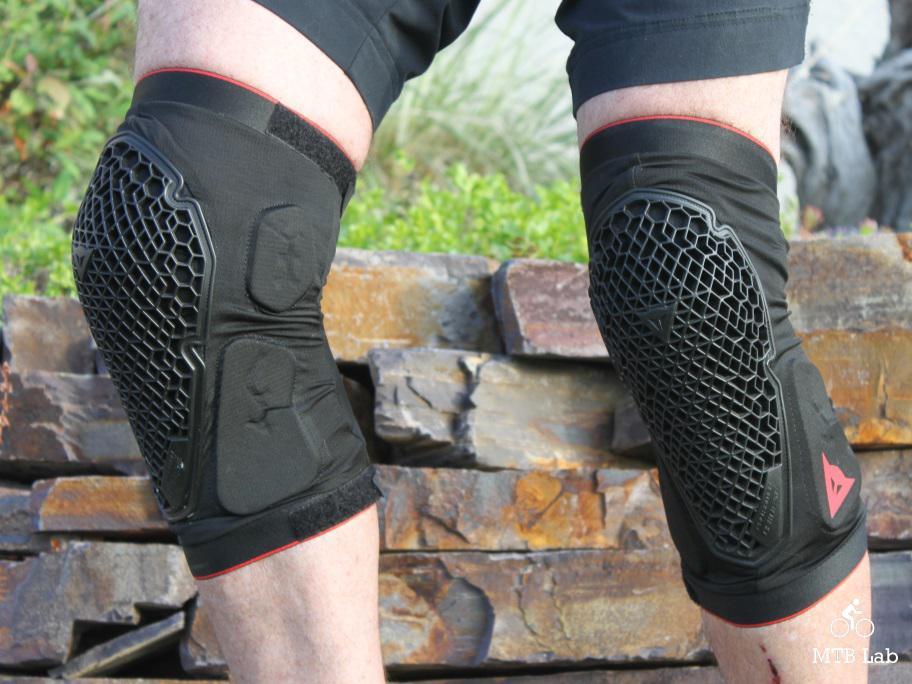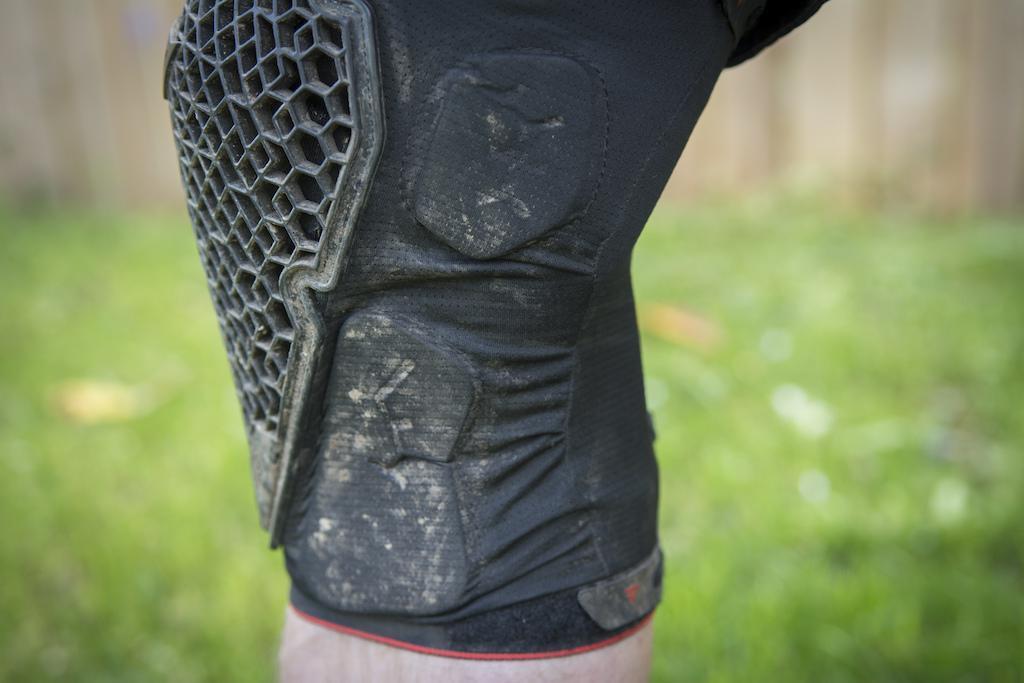The first image is the image on the left, the second image is the image on the right. Considering the images on both sides, is "Both images show kneepads modelled on human legs." valid? Answer yes or no. Yes. The first image is the image on the left, the second image is the image on the right. For the images shown, is this caption "An image shows a front view of a pair of legs wearing mesh-like kneepads." true? Answer yes or no. Yes. 